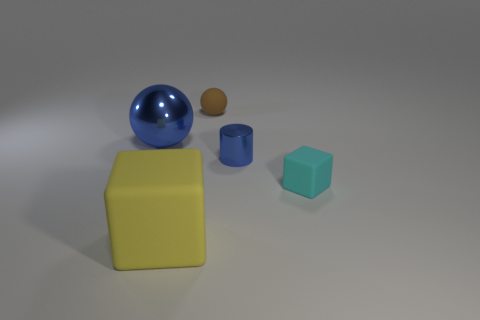Add 3 tiny gray balls. How many objects exist? 8 Subtract all balls. How many objects are left? 3 Add 2 large objects. How many large objects are left? 4 Add 2 blue things. How many blue things exist? 4 Subtract 0 gray spheres. How many objects are left? 5 Subtract all small cyan matte things. Subtract all big blue metal objects. How many objects are left? 3 